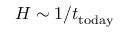Convert formula to latex. <formula><loc_0><loc_0><loc_500><loc_500>H \sim 1 / t _ { t o d a y }</formula> 